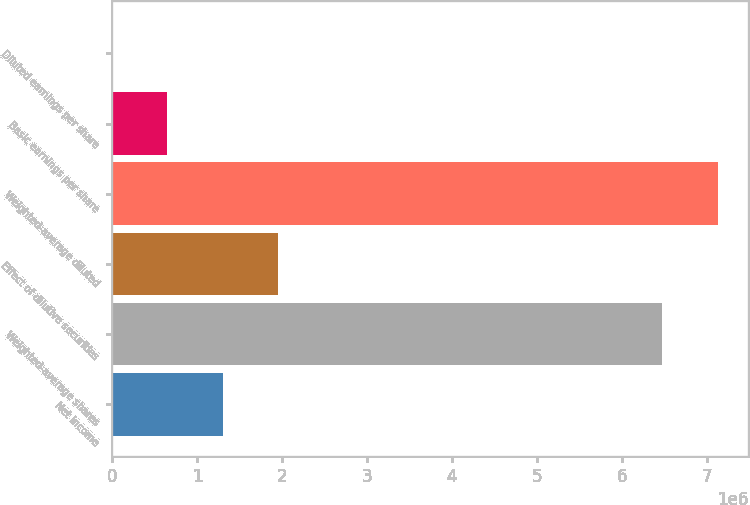<chart> <loc_0><loc_0><loc_500><loc_500><bar_chart><fcel>Net income<fcel>Weighted-average shares<fcel>Effect of dilutive securities<fcel>Weighted-average diluted<fcel>Basic earnings per share<fcel>Diluted earnings per share<nl><fcel>1.30433e+06<fcel>6.47732e+06<fcel>1.95649e+06<fcel>7.12948e+06<fcel>652169<fcel>5.68<nl></chart> 